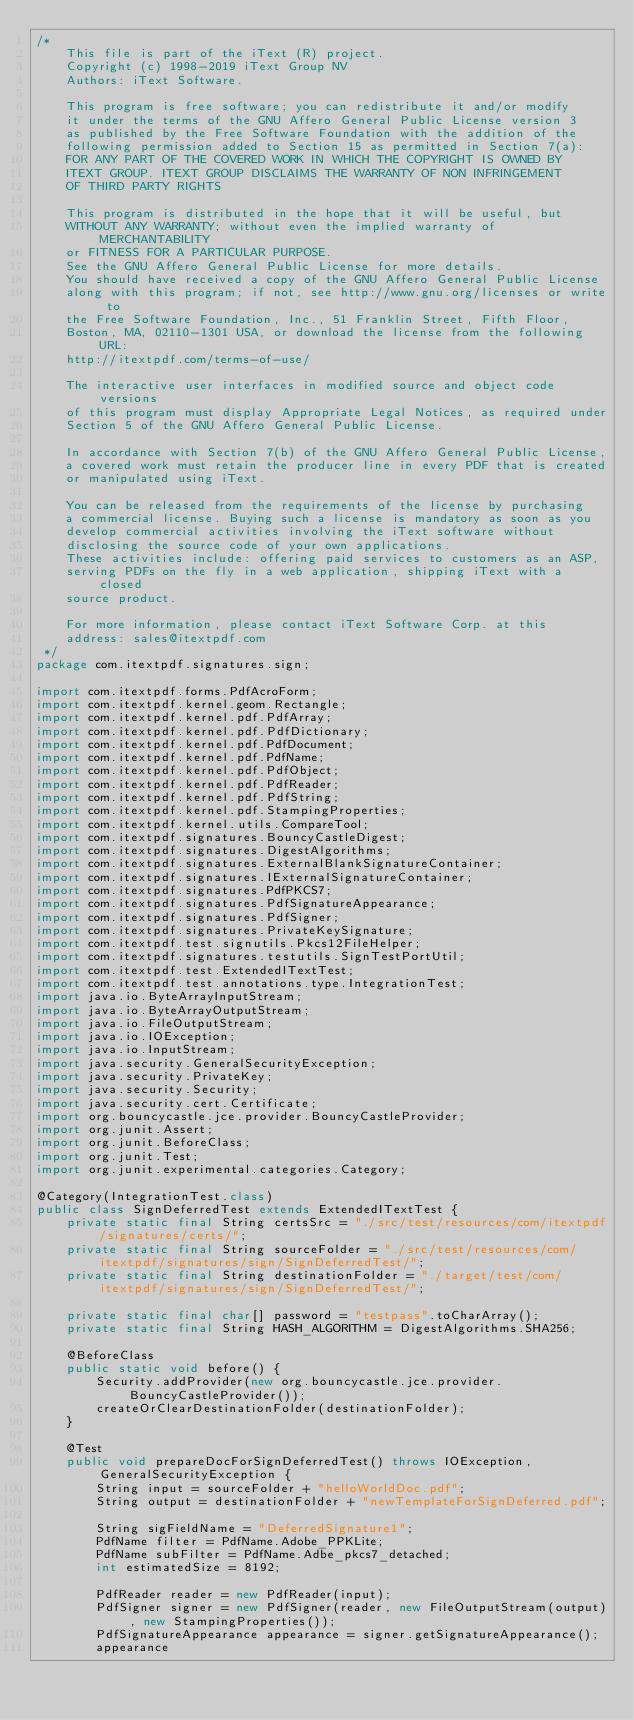<code> <loc_0><loc_0><loc_500><loc_500><_Java_>/*
    This file is part of the iText (R) project.
    Copyright (c) 1998-2019 iText Group NV
    Authors: iText Software.

    This program is free software; you can redistribute it and/or modify
    it under the terms of the GNU Affero General Public License version 3
    as published by the Free Software Foundation with the addition of the
    following permission added to Section 15 as permitted in Section 7(a):
    FOR ANY PART OF THE COVERED WORK IN WHICH THE COPYRIGHT IS OWNED BY
    ITEXT GROUP. ITEXT GROUP DISCLAIMS THE WARRANTY OF NON INFRINGEMENT
    OF THIRD PARTY RIGHTS

    This program is distributed in the hope that it will be useful, but
    WITHOUT ANY WARRANTY; without even the implied warranty of MERCHANTABILITY
    or FITNESS FOR A PARTICULAR PURPOSE.
    See the GNU Affero General Public License for more details.
    You should have received a copy of the GNU Affero General Public License
    along with this program; if not, see http://www.gnu.org/licenses or write to
    the Free Software Foundation, Inc., 51 Franklin Street, Fifth Floor,
    Boston, MA, 02110-1301 USA, or download the license from the following URL:
    http://itextpdf.com/terms-of-use/

    The interactive user interfaces in modified source and object code versions
    of this program must display Appropriate Legal Notices, as required under
    Section 5 of the GNU Affero General Public License.

    In accordance with Section 7(b) of the GNU Affero General Public License,
    a covered work must retain the producer line in every PDF that is created
    or manipulated using iText.

    You can be released from the requirements of the license by purchasing
    a commercial license. Buying such a license is mandatory as soon as you
    develop commercial activities involving the iText software without
    disclosing the source code of your own applications.
    These activities include: offering paid services to customers as an ASP,
    serving PDFs on the fly in a web application, shipping iText with a closed
    source product.

    For more information, please contact iText Software Corp. at this
    address: sales@itextpdf.com
 */
package com.itextpdf.signatures.sign;

import com.itextpdf.forms.PdfAcroForm;
import com.itextpdf.kernel.geom.Rectangle;
import com.itextpdf.kernel.pdf.PdfArray;
import com.itextpdf.kernel.pdf.PdfDictionary;
import com.itextpdf.kernel.pdf.PdfDocument;
import com.itextpdf.kernel.pdf.PdfName;
import com.itextpdf.kernel.pdf.PdfObject;
import com.itextpdf.kernel.pdf.PdfReader;
import com.itextpdf.kernel.pdf.PdfString;
import com.itextpdf.kernel.pdf.StampingProperties;
import com.itextpdf.kernel.utils.CompareTool;
import com.itextpdf.signatures.BouncyCastleDigest;
import com.itextpdf.signatures.DigestAlgorithms;
import com.itextpdf.signatures.ExternalBlankSignatureContainer;
import com.itextpdf.signatures.IExternalSignatureContainer;
import com.itextpdf.signatures.PdfPKCS7;
import com.itextpdf.signatures.PdfSignatureAppearance;
import com.itextpdf.signatures.PdfSigner;
import com.itextpdf.signatures.PrivateKeySignature;
import com.itextpdf.test.signutils.Pkcs12FileHelper;
import com.itextpdf.signatures.testutils.SignTestPortUtil;
import com.itextpdf.test.ExtendedITextTest;
import com.itextpdf.test.annotations.type.IntegrationTest;
import java.io.ByteArrayInputStream;
import java.io.ByteArrayOutputStream;
import java.io.FileOutputStream;
import java.io.IOException;
import java.io.InputStream;
import java.security.GeneralSecurityException;
import java.security.PrivateKey;
import java.security.Security;
import java.security.cert.Certificate;
import org.bouncycastle.jce.provider.BouncyCastleProvider;
import org.junit.Assert;
import org.junit.BeforeClass;
import org.junit.Test;
import org.junit.experimental.categories.Category;

@Category(IntegrationTest.class)
public class SignDeferredTest extends ExtendedITextTest {
    private static final String certsSrc = "./src/test/resources/com/itextpdf/signatures/certs/";
    private static final String sourceFolder = "./src/test/resources/com/itextpdf/signatures/sign/SignDeferredTest/";
    private static final String destinationFolder = "./target/test/com/itextpdf/signatures/sign/SignDeferredTest/";

    private static final char[] password = "testpass".toCharArray();
    private static final String HASH_ALGORITHM = DigestAlgorithms.SHA256;

    @BeforeClass
    public static void before() {
        Security.addProvider(new org.bouncycastle.jce.provider.BouncyCastleProvider());
        createOrClearDestinationFolder(destinationFolder);
    }

    @Test
    public void prepareDocForSignDeferredTest() throws IOException, GeneralSecurityException {
        String input = sourceFolder + "helloWorldDoc.pdf";
        String output = destinationFolder + "newTemplateForSignDeferred.pdf";

        String sigFieldName = "DeferredSignature1";
        PdfName filter = PdfName.Adobe_PPKLite;
        PdfName subFilter = PdfName.Adbe_pkcs7_detached;
        int estimatedSize = 8192;

        PdfReader reader = new PdfReader(input);
        PdfSigner signer = new PdfSigner(reader, new FileOutputStream(output), new StampingProperties());
        PdfSignatureAppearance appearance = signer.getSignatureAppearance();
        appearance</code> 